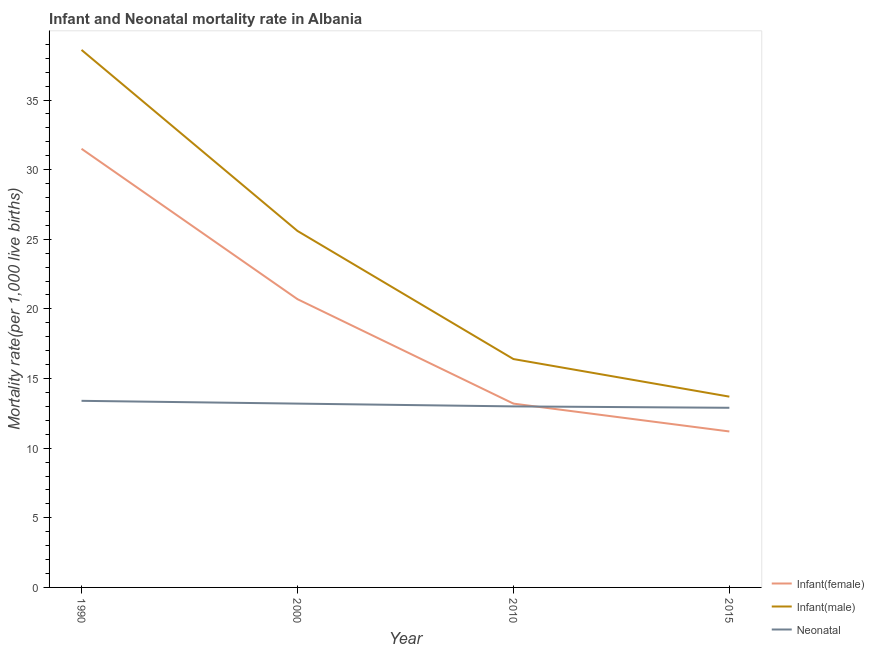How many different coloured lines are there?
Ensure brevity in your answer.  3. Does the line corresponding to infant mortality rate(female) intersect with the line corresponding to neonatal mortality rate?
Provide a short and direct response. Yes. What is the neonatal mortality rate in 2015?
Offer a very short reply. 12.9. In which year was the neonatal mortality rate maximum?
Provide a short and direct response. 1990. In which year was the neonatal mortality rate minimum?
Make the answer very short. 2015. What is the total infant mortality rate(male) in the graph?
Provide a succinct answer. 94.3. What is the difference between the neonatal mortality rate in 2010 and the infant mortality rate(female) in 1990?
Ensure brevity in your answer.  -18.5. What is the average infant mortality rate(male) per year?
Your answer should be compact. 23.57. In the year 2010, what is the difference between the infant mortality rate(male) and infant mortality rate(female)?
Offer a terse response. 3.2. In how many years, is the infant mortality rate(male) greater than 10?
Offer a very short reply. 4. What is the ratio of the infant mortality rate(male) in 1990 to that in 2010?
Offer a very short reply. 2.35. Is the infant mortality rate(female) in 1990 less than that in 2015?
Offer a very short reply. No. Is the difference between the infant mortality rate(male) in 2000 and 2015 greater than the difference between the neonatal mortality rate in 2000 and 2015?
Your answer should be compact. Yes. What is the difference between the highest and the lowest neonatal mortality rate?
Your answer should be very brief. 0.5. In how many years, is the neonatal mortality rate greater than the average neonatal mortality rate taken over all years?
Offer a very short reply. 2. Does the infant mortality rate(male) monotonically increase over the years?
Give a very brief answer. No. Is the infant mortality rate(female) strictly greater than the neonatal mortality rate over the years?
Ensure brevity in your answer.  No. Are the values on the major ticks of Y-axis written in scientific E-notation?
Make the answer very short. No. Does the graph contain grids?
Offer a very short reply. No. Where does the legend appear in the graph?
Make the answer very short. Bottom right. How many legend labels are there?
Your answer should be very brief. 3. How are the legend labels stacked?
Give a very brief answer. Vertical. What is the title of the graph?
Keep it short and to the point. Infant and Neonatal mortality rate in Albania. What is the label or title of the Y-axis?
Your response must be concise. Mortality rate(per 1,0 live births). What is the Mortality rate(per 1,000 live births) in Infant(female) in 1990?
Provide a short and direct response. 31.5. What is the Mortality rate(per 1,000 live births) in Infant(male) in 1990?
Make the answer very short. 38.6. What is the Mortality rate(per 1,000 live births) of Neonatal  in 1990?
Offer a terse response. 13.4. What is the Mortality rate(per 1,000 live births) in Infant(female) in 2000?
Provide a succinct answer. 20.7. What is the Mortality rate(per 1,000 live births) of Infant(male) in 2000?
Offer a terse response. 25.6. What is the Mortality rate(per 1,000 live births) in Infant(male) in 2010?
Provide a succinct answer. 16.4. What is the Mortality rate(per 1,000 live births) in Neonatal  in 2015?
Provide a short and direct response. 12.9. Across all years, what is the maximum Mortality rate(per 1,000 live births) in Infant(female)?
Offer a very short reply. 31.5. Across all years, what is the maximum Mortality rate(per 1,000 live births) of Infant(male)?
Ensure brevity in your answer.  38.6. Across all years, what is the minimum Mortality rate(per 1,000 live births) of Infant(female)?
Your response must be concise. 11.2. Across all years, what is the minimum Mortality rate(per 1,000 live births) in Neonatal ?
Your response must be concise. 12.9. What is the total Mortality rate(per 1,000 live births) in Infant(female) in the graph?
Offer a very short reply. 76.6. What is the total Mortality rate(per 1,000 live births) in Infant(male) in the graph?
Keep it short and to the point. 94.3. What is the total Mortality rate(per 1,000 live births) of Neonatal  in the graph?
Your response must be concise. 52.5. What is the difference between the Mortality rate(per 1,000 live births) of Infant(female) in 1990 and that in 2000?
Your answer should be very brief. 10.8. What is the difference between the Mortality rate(per 1,000 live births) of Neonatal  in 1990 and that in 2000?
Ensure brevity in your answer.  0.2. What is the difference between the Mortality rate(per 1,000 live births) of Infant(female) in 1990 and that in 2010?
Offer a terse response. 18.3. What is the difference between the Mortality rate(per 1,000 live births) in Infant(male) in 1990 and that in 2010?
Offer a terse response. 22.2. What is the difference between the Mortality rate(per 1,000 live births) of Infant(female) in 1990 and that in 2015?
Your answer should be very brief. 20.3. What is the difference between the Mortality rate(per 1,000 live births) of Infant(male) in 1990 and that in 2015?
Your answer should be compact. 24.9. What is the difference between the Mortality rate(per 1,000 live births) in Infant(male) in 2000 and that in 2010?
Offer a terse response. 9.2. What is the difference between the Mortality rate(per 1,000 live births) of Neonatal  in 2000 and that in 2010?
Make the answer very short. 0.2. What is the difference between the Mortality rate(per 1,000 live births) of Infant(male) in 2000 and that in 2015?
Offer a very short reply. 11.9. What is the difference between the Mortality rate(per 1,000 live births) in Infant(female) in 1990 and the Mortality rate(per 1,000 live births) in Infant(male) in 2000?
Your answer should be very brief. 5.9. What is the difference between the Mortality rate(per 1,000 live births) of Infant(male) in 1990 and the Mortality rate(per 1,000 live births) of Neonatal  in 2000?
Your response must be concise. 25.4. What is the difference between the Mortality rate(per 1,000 live births) in Infant(male) in 1990 and the Mortality rate(per 1,000 live births) in Neonatal  in 2010?
Offer a terse response. 25.6. What is the difference between the Mortality rate(per 1,000 live births) in Infant(female) in 1990 and the Mortality rate(per 1,000 live births) in Neonatal  in 2015?
Offer a terse response. 18.6. What is the difference between the Mortality rate(per 1,000 live births) of Infant(male) in 1990 and the Mortality rate(per 1,000 live births) of Neonatal  in 2015?
Give a very brief answer. 25.7. What is the difference between the Mortality rate(per 1,000 live births) in Infant(female) in 2000 and the Mortality rate(per 1,000 live births) in Infant(male) in 2010?
Keep it short and to the point. 4.3. What is the difference between the Mortality rate(per 1,000 live births) of Infant(female) in 2000 and the Mortality rate(per 1,000 live births) of Neonatal  in 2015?
Provide a succinct answer. 7.8. What is the difference between the Mortality rate(per 1,000 live births) of Infant(male) in 2000 and the Mortality rate(per 1,000 live births) of Neonatal  in 2015?
Provide a short and direct response. 12.7. What is the difference between the Mortality rate(per 1,000 live births) of Infant(female) in 2010 and the Mortality rate(per 1,000 live births) of Infant(male) in 2015?
Give a very brief answer. -0.5. What is the difference between the Mortality rate(per 1,000 live births) of Infant(female) in 2010 and the Mortality rate(per 1,000 live births) of Neonatal  in 2015?
Ensure brevity in your answer.  0.3. What is the average Mortality rate(per 1,000 live births) of Infant(female) per year?
Your answer should be very brief. 19.15. What is the average Mortality rate(per 1,000 live births) of Infant(male) per year?
Your response must be concise. 23.57. What is the average Mortality rate(per 1,000 live births) of Neonatal  per year?
Your response must be concise. 13.12. In the year 1990, what is the difference between the Mortality rate(per 1,000 live births) of Infant(female) and Mortality rate(per 1,000 live births) of Infant(male)?
Your response must be concise. -7.1. In the year 1990, what is the difference between the Mortality rate(per 1,000 live births) of Infant(female) and Mortality rate(per 1,000 live births) of Neonatal ?
Provide a succinct answer. 18.1. In the year 1990, what is the difference between the Mortality rate(per 1,000 live births) of Infant(male) and Mortality rate(per 1,000 live births) of Neonatal ?
Your answer should be very brief. 25.2. In the year 2000, what is the difference between the Mortality rate(per 1,000 live births) in Infant(female) and Mortality rate(per 1,000 live births) in Neonatal ?
Your response must be concise. 7.5. In the year 2000, what is the difference between the Mortality rate(per 1,000 live births) in Infant(male) and Mortality rate(per 1,000 live births) in Neonatal ?
Keep it short and to the point. 12.4. In the year 2010, what is the difference between the Mortality rate(per 1,000 live births) of Infant(female) and Mortality rate(per 1,000 live births) of Infant(male)?
Provide a succinct answer. -3.2. In the year 2010, what is the difference between the Mortality rate(per 1,000 live births) in Infant(male) and Mortality rate(per 1,000 live births) in Neonatal ?
Provide a short and direct response. 3.4. In the year 2015, what is the difference between the Mortality rate(per 1,000 live births) in Infant(female) and Mortality rate(per 1,000 live births) in Infant(male)?
Make the answer very short. -2.5. What is the ratio of the Mortality rate(per 1,000 live births) in Infant(female) in 1990 to that in 2000?
Ensure brevity in your answer.  1.52. What is the ratio of the Mortality rate(per 1,000 live births) in Infant(male) in 1990 to that in 2000?
Your answer should be compact. 1.51. What is the ratio of the Mortality rate(per 1,000 live births) of Neonatal  in 1990 to that in 2000?
Ensure brevity in your answer.  1.02. What is the ratio of the Mortality rate(per 1,000 live births) in Infant(female) in 1990 to that in 2010?
Provide a short and direct response. 2.39. What is the ratio of the Mortality rate(per 1,000 live births) in Infant(male) in 1990 to that in 2010?
Make the answer very short. 2.35. What is the ratio of the Mortality rate(per 1,000 live births) of Neonatal  in 1990 to that in 2010?
Your answer should be very brief. 1.03. What is the ratio of the Mortality rate(per 1,000 live births) of Infant(female) in 1990 to that in 2015?
Provide a succinct answer. 2.81. What is the ratio of the Mortality rate(per 1,000 live births) in Infant(male) in 1990 to that in 2015?
Keep it short and to the point. 2.82. What is the ratio of the Mortality rate(per 1,000 live births) of Neonatal  in 1990 to that in 2015?
Give a very brief answer. 1.04. What is the ratio of the Mortality rate(per 1,000 live births) in Infant(female) in 2000 to that in 2010?
Offer a terse response. 1.57. What is the ratio of the Mortality rate(per 1,000 live births) of Infant(male) in 2000 to that in 2010?
Give a very brief answer. 1.56. What is the ratio of the Mortality rate(per 1,000 live births) in Neonatal  in 2000 to that in 2010?
Offer a very short reply. 1.02. What is the ratio of the Mortality rate(per 1,000 live births) of Infant(female) in 2000 to that in 2015?
Offer a very short reply. 1.85. What is the ratio of the Mortality rate(per 1,000 live births) in Infant(male) in 2000 to that in 2015?
Provide a succinct answer. 1.87. What is the ratio of the Mortality rate(per 1,000 live births) in Neonatal  in 2000 to that in 2015?
Make the answer very short. 1.02. What is the ratio of the Mortality rate(per 1,000 live births) in Infant(female) in 2010 to that in 2015?
Offer a terse response. 1.18. What is the ratio of the Mortality rate(per 1,000 live births) of Infant(male) in 2010 to that in 2015?
Your answer should be compact. 1.2. What is the ratio of the Mortality rate(per 1,000 live births) of Neonatal  in 2010 to that in 2015?
Make the answer very short. 1.01. What is the difference between the highest and the second highest Mortality rate(per 1,000 live births) in Infant(female)?
Offer a very short reply. 10.8. What is the difference between the highest and the second highest Mortality rate(per 1,000 live births) of Neonatal ?
Provide a succinct answer. 0.2. What is the difference between the highest and the lowest Mortality rate(per 1,000 live births) of Infant(female)?
Your answer should be compact. 20.3. What is the difference between the highest and the lowest Mortality rate(per 1,000 live births) of Infant(male)?
Your answer should be compact. 24.9. 